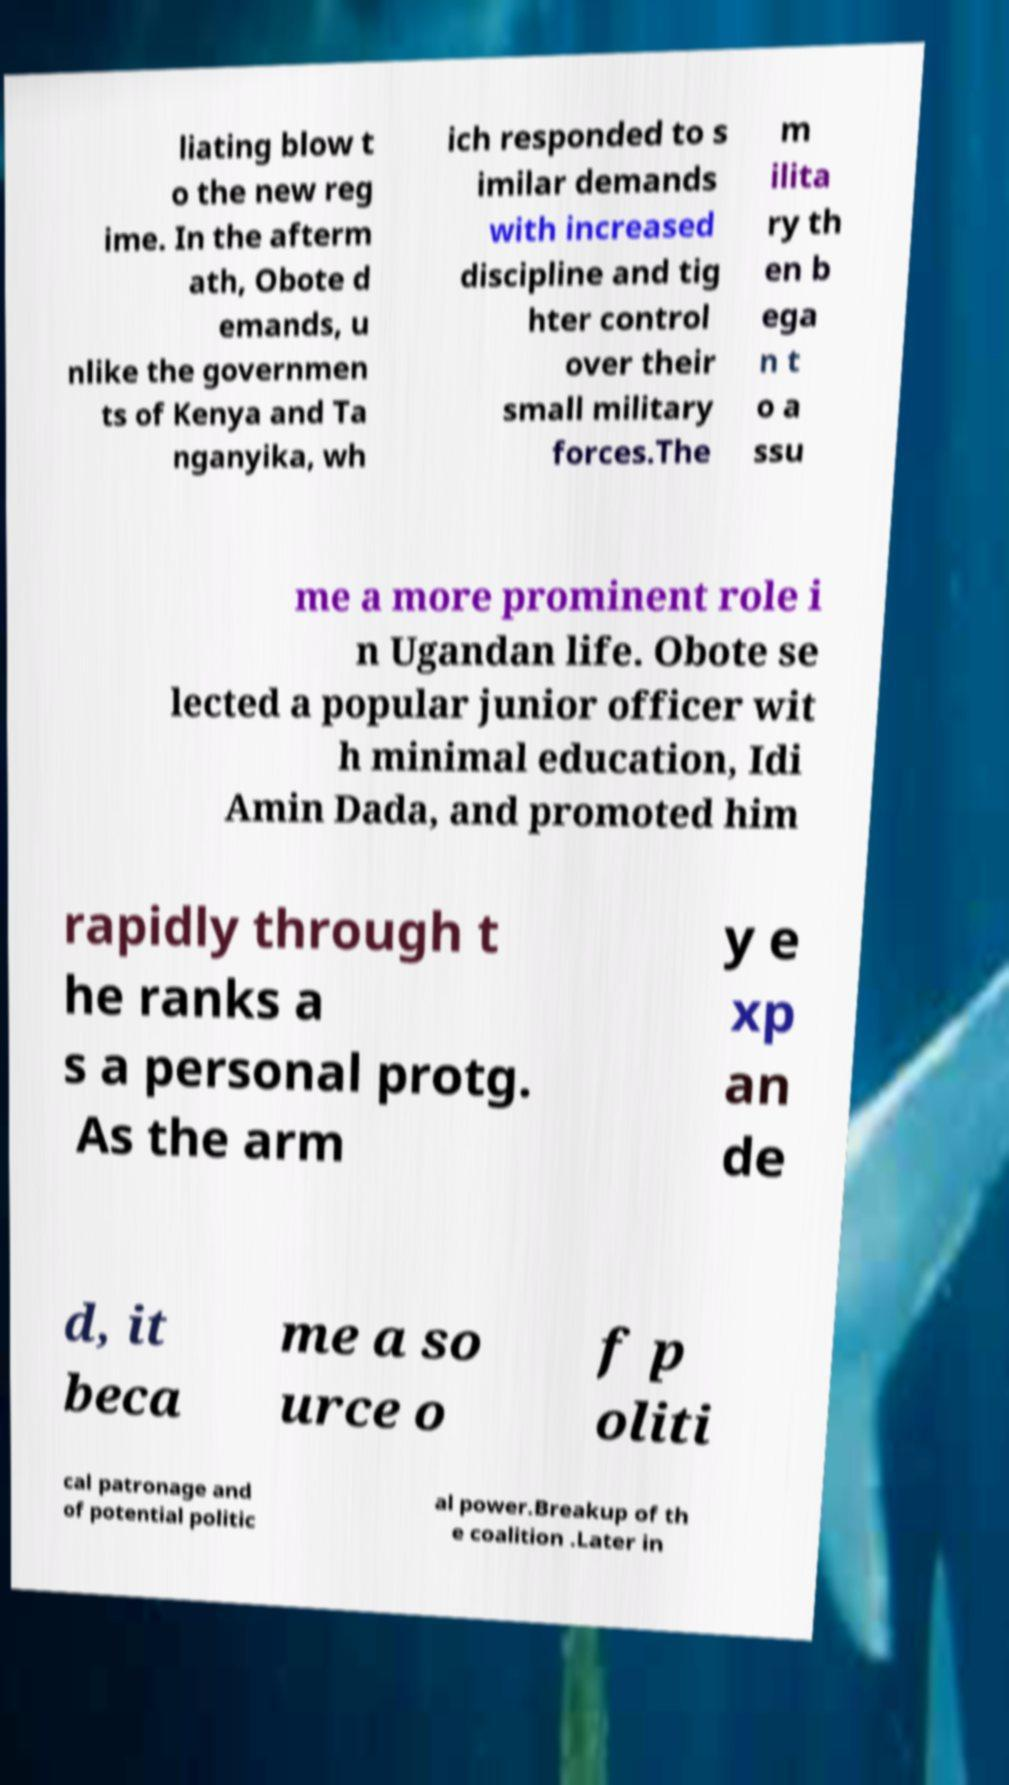There's text embedded in this image that I need extracted. Can you transcribe it verbatim? liating blow t o the new reg ime. In the afterm ath, Obote d emands, u nlike the governmen ts of Kenya and Ta nganyika, wh ich responded to s imilar demands with increased discipline and tig hter control over their small military forces.The m ilita ry th en b ega n t o a ssu me a more prominent role i n Ugandan life. Obote se lected a popular junior officer wit h minimal education, Idi Amin Dada, and promoted him rapidly through t he ranks a s a personal protg. As the arm y e xp an de d, it beca me a so urce o f p oliti cal patronage and of potential politic al power.Breakup of th e coalition .Later in 